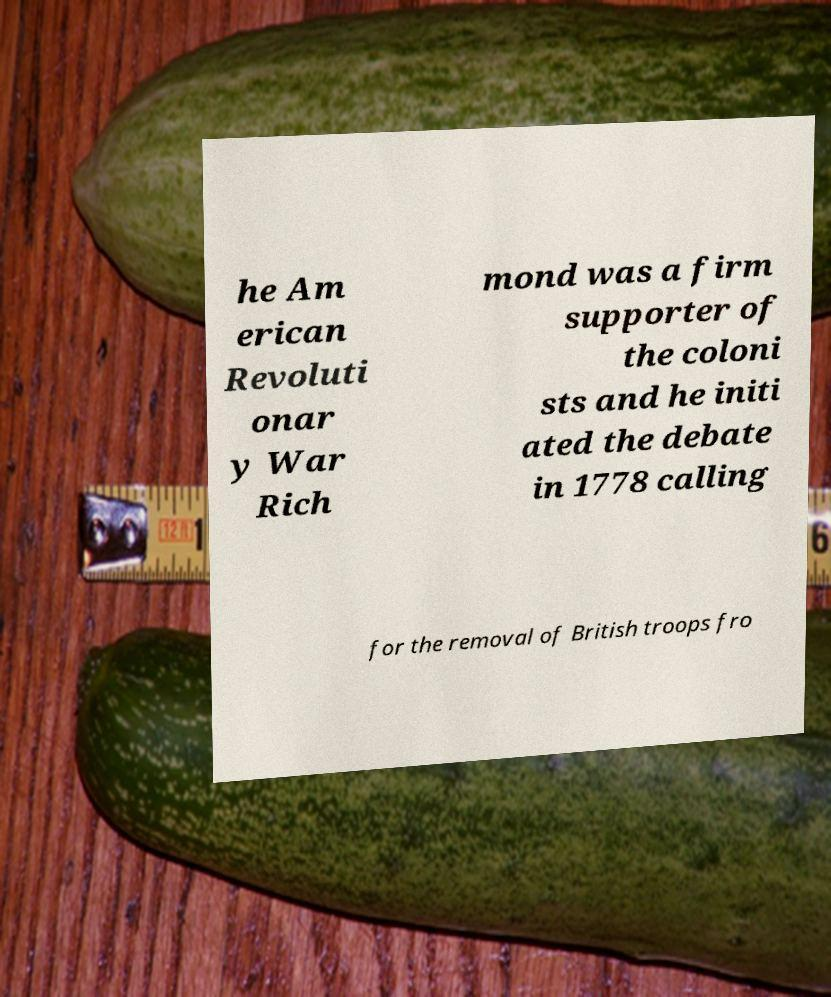Can you read and provide the text displayed in the image?This photo seems to have some interesting text. Can you extract and type it out for me? he Am erican Revoluti onar y War Rich mond was a firm supporter of the coloni sts and he initi ated the debate in 1778 calling for the removal of British troops fro 